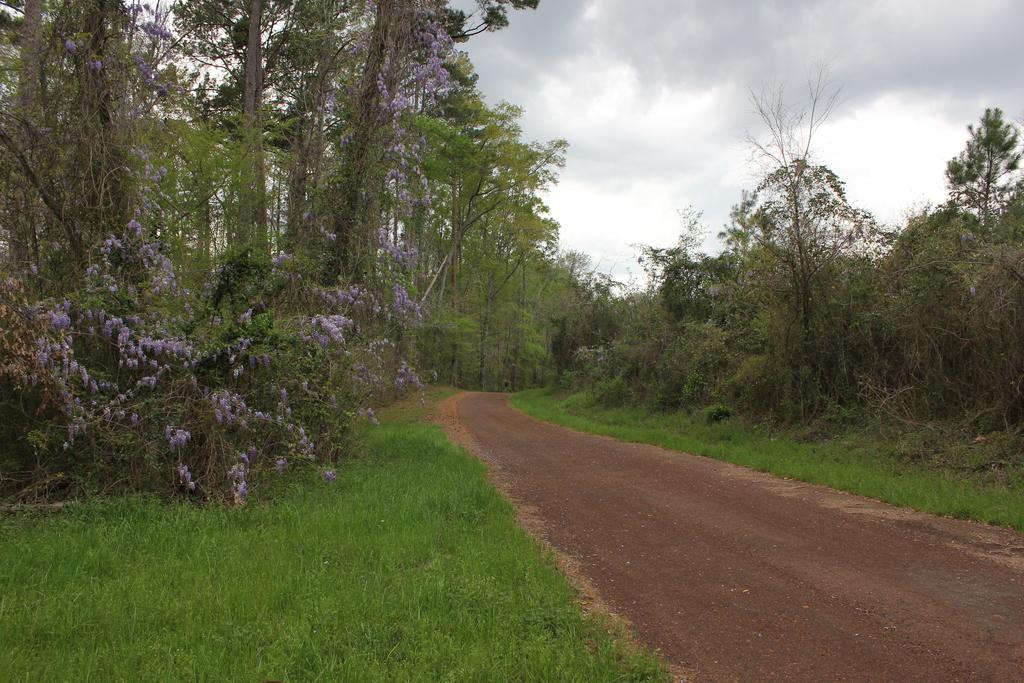What type of vegetation can be seen on the right side of the image? There are plants, trees, and grass on the right side of the image. What type of vegetation can be seen on the left side of the image? There are plants, trees, and grass on the left side of the image. What is the surface that people might walk on in the image? There is a walkway at the bottom of the image. What is visible at the top of the image? The sky is visible at the top of the image. Can you see any kites flying in the sky in the image? There are no kites visible in the sky in the image. Is there a harbor with boats in the image? There is no harbor or boats present in the image. 